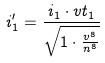<formula> <loc_0><loc_0><loc_500><loc_500>i _ { 1 } ^ { \prime } = \frac { i _ { 1 } \cdot v t _ { 1 } } { \sqrt { 1 \cdot \frac { v ^ { 8 } } { n ^ { 8 } } } }</formula> 